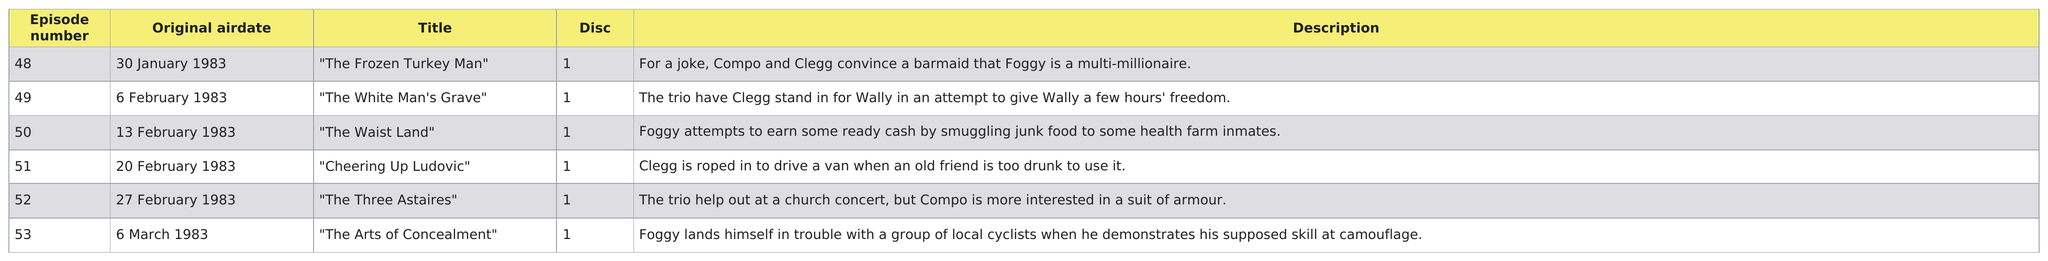Outline some significant characteristics in this image. There are 6 episodes in series 7 (1983). In the episode summaries, Clegg is mentioned the most. In Episode 48, there is a reference to competitions and its description, as well as a mention of Clegg. Of the episodes, 4 had their original airdate in February. February has aired four episodes. 